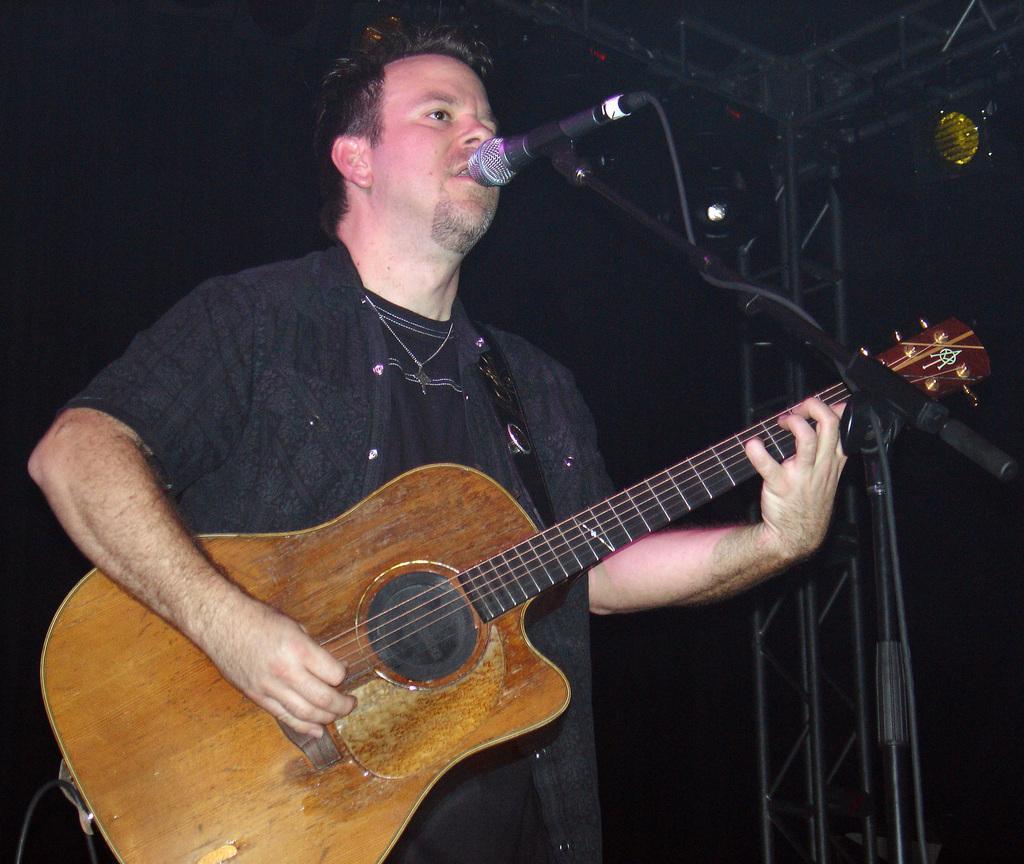Please provide a concise description of this image. Here in the center we can see one person is singing which we can see on his face where his mouth is open. And in front of him there is a microphone. And he is playing guitar. 